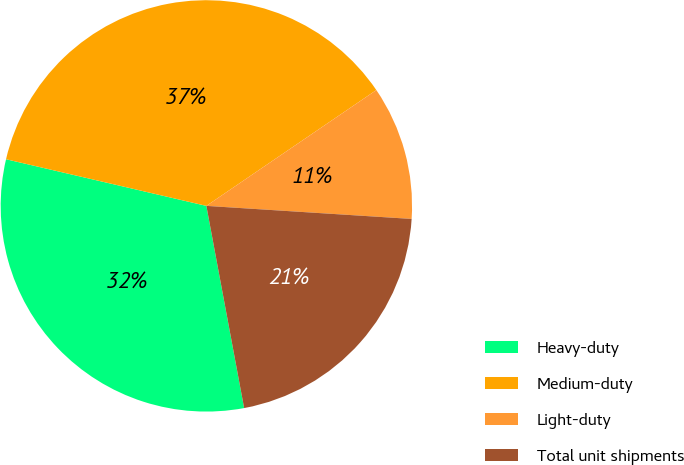Convert chart. <chart><loc_0><loc_0><loc_500><loc_500><pie_chart><fcel>Heavy-duty<fcel>Medium-duty<fcel>Light-duty<fcel>Total unit shipments<nl><fcel>31.58%<fcel>36.84%<fcel>10.53%<fcel>21.05%<nl></chart> 